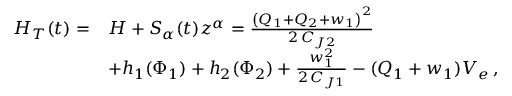Convert formula to latex. <formula><loc_0><loc_0><loc_500><loc_500>\begin{array} { r l } { H _ { T } ( t ) = } & { H + S _ { \alpha } ( t ) z ^ { \alpha } = \frac { { \left ( Q _ { 1 } + Q _ { 2 } + w _ { 1 } \right ) } ^ { 2 } } { 2 \, C _ { J 2 } } } \\ & { + h _ { 1 } ( \Phi _ { 1 } ) + h _ { 2 } ( \Phi _ { 2 } ) + \frac { w _ { 1 } ^ { 2 } } { 2 \, C _ { J 1 } } - ( Q _ { 1 } + w _ { 1 } ) V _ { e } \, , } \end{array}</formula> 